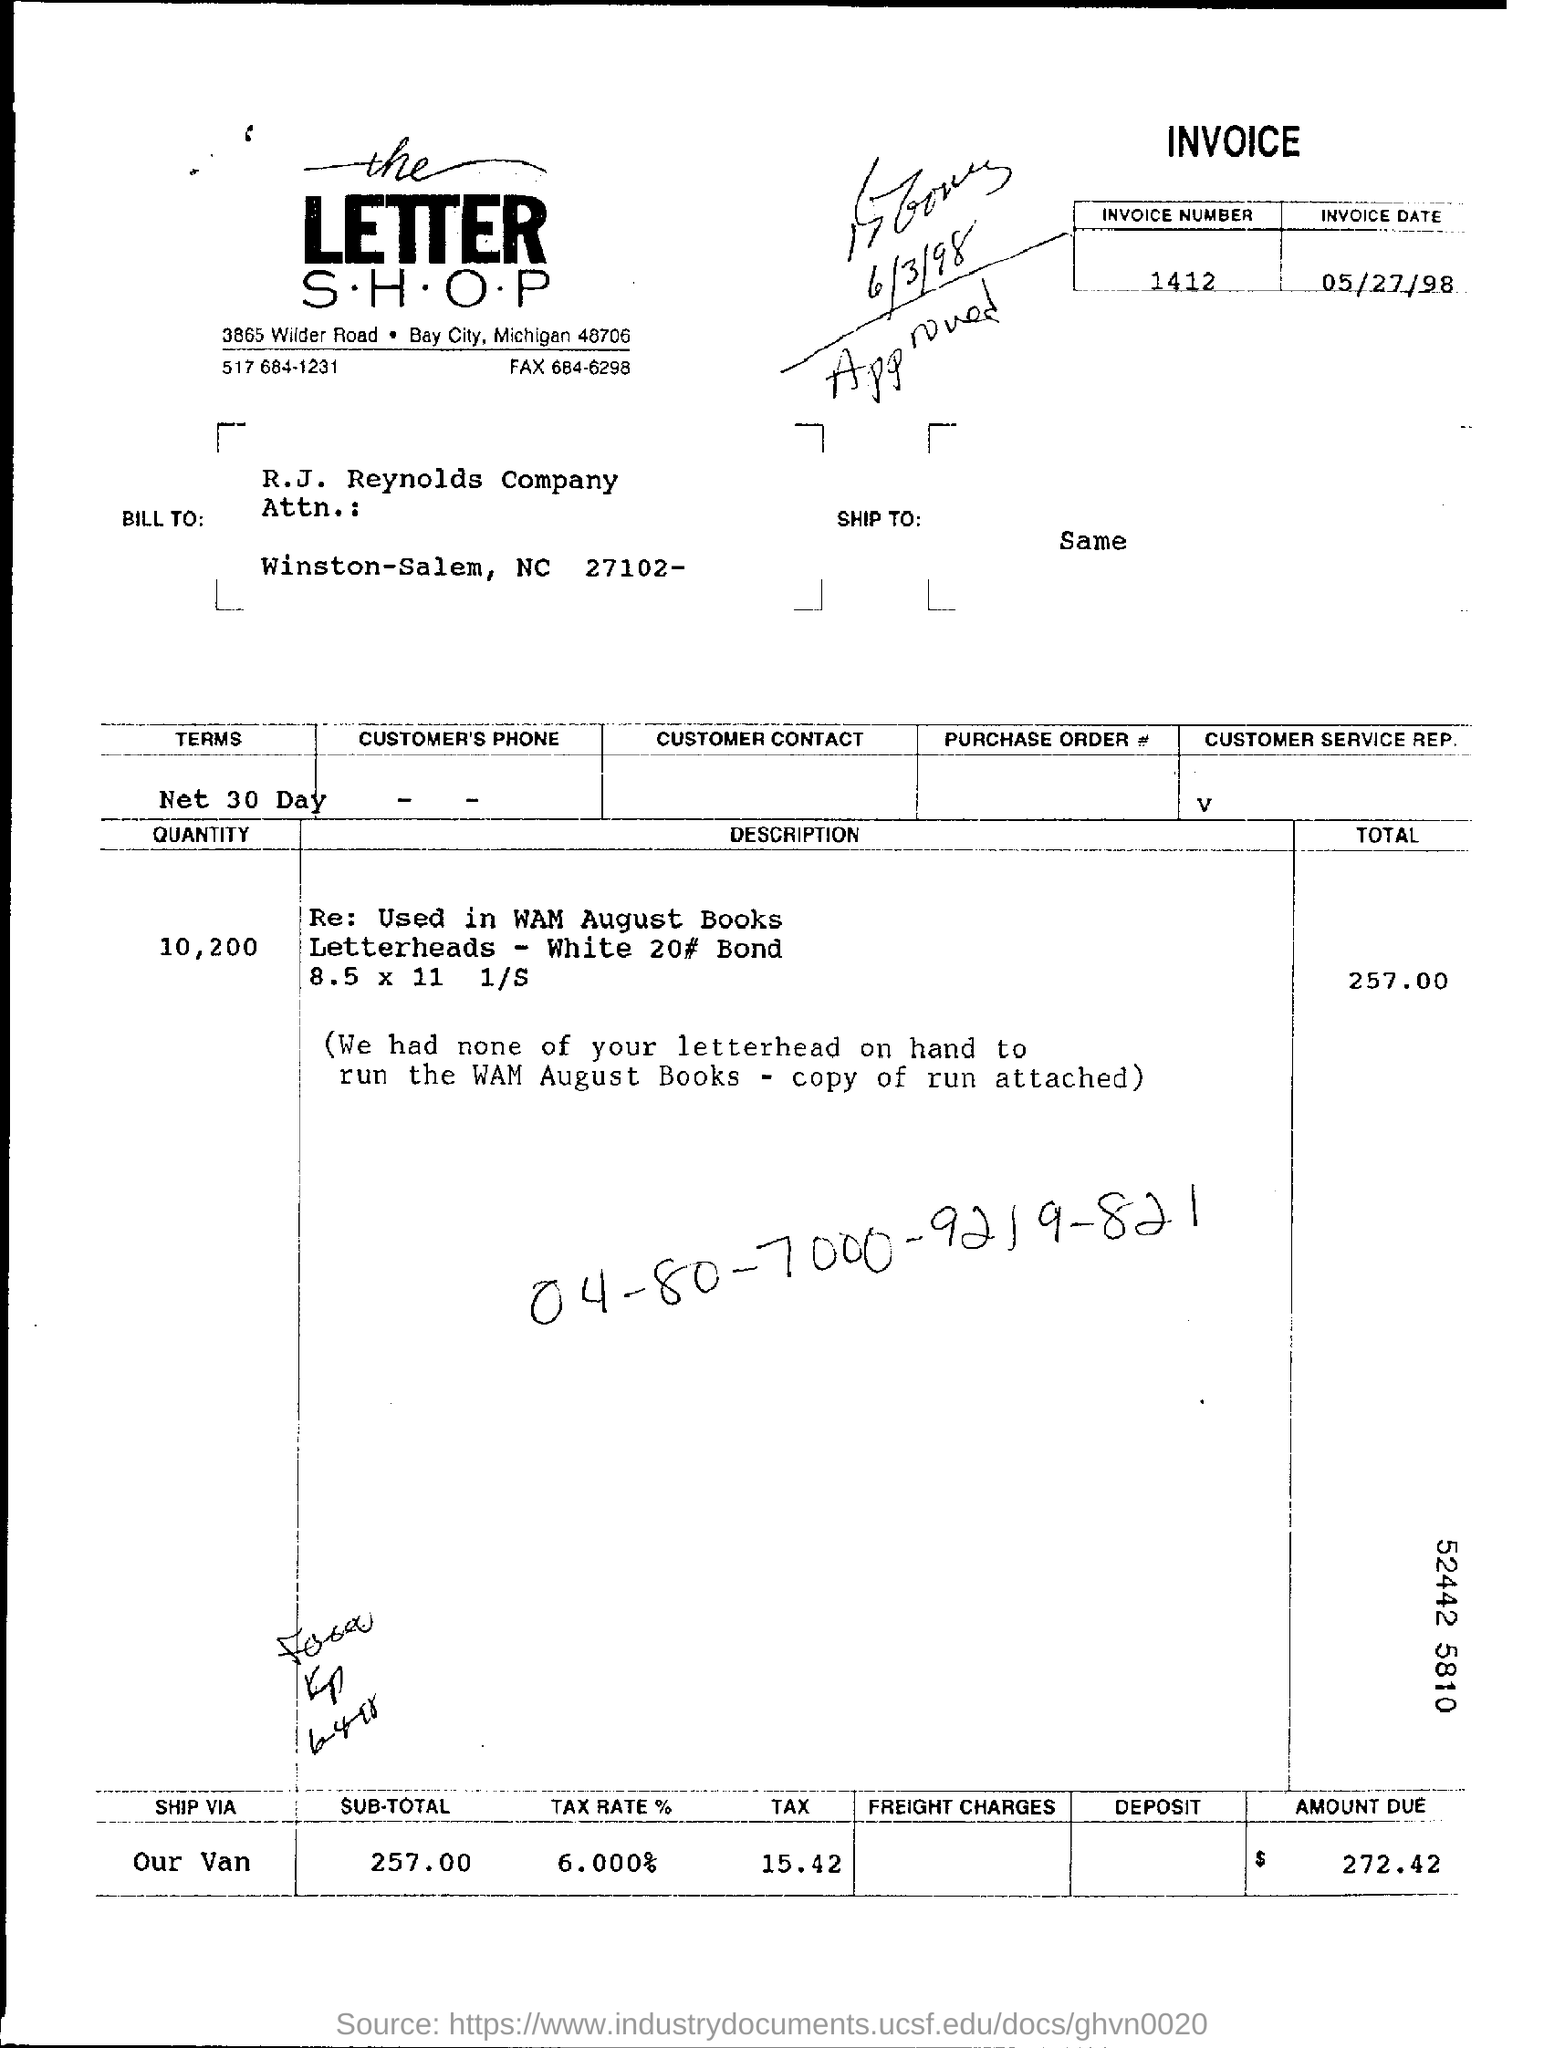What is the Invoice Number?
Your answer should be very brief. 1412. What is the Invoice Date?
Your answer should be very brief. 05/27/98. What is the Quantity?
Give a very brief answer. 10,200. What is the Total?
Your response must be concise. 257.00. 